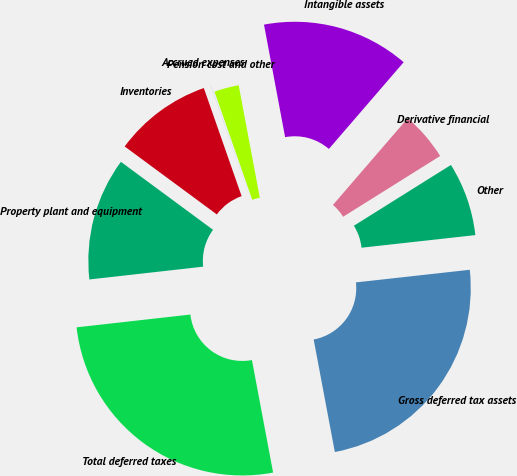<chart> <loc_0><loc_0><loc_500><loc_500><pie_chart><fcel>Property plant and equipment<fcel>Inventories<fcel>Accrued expenses<fcel>Pension cost and other<fcel>Intangible assets<fcel>Derivative financial<fcel>Other<fcel>Gross deferred tax assets<fcel>Total deferred taxes<nl><fcel>11.9%<fcel>9.53%<fcel>0.01%<fcel>2.39%<fcel>14.28%<fcel>4.77%<fcel>7.15%<fcel>23.8%<fcel>26.18%<nl></chart> 